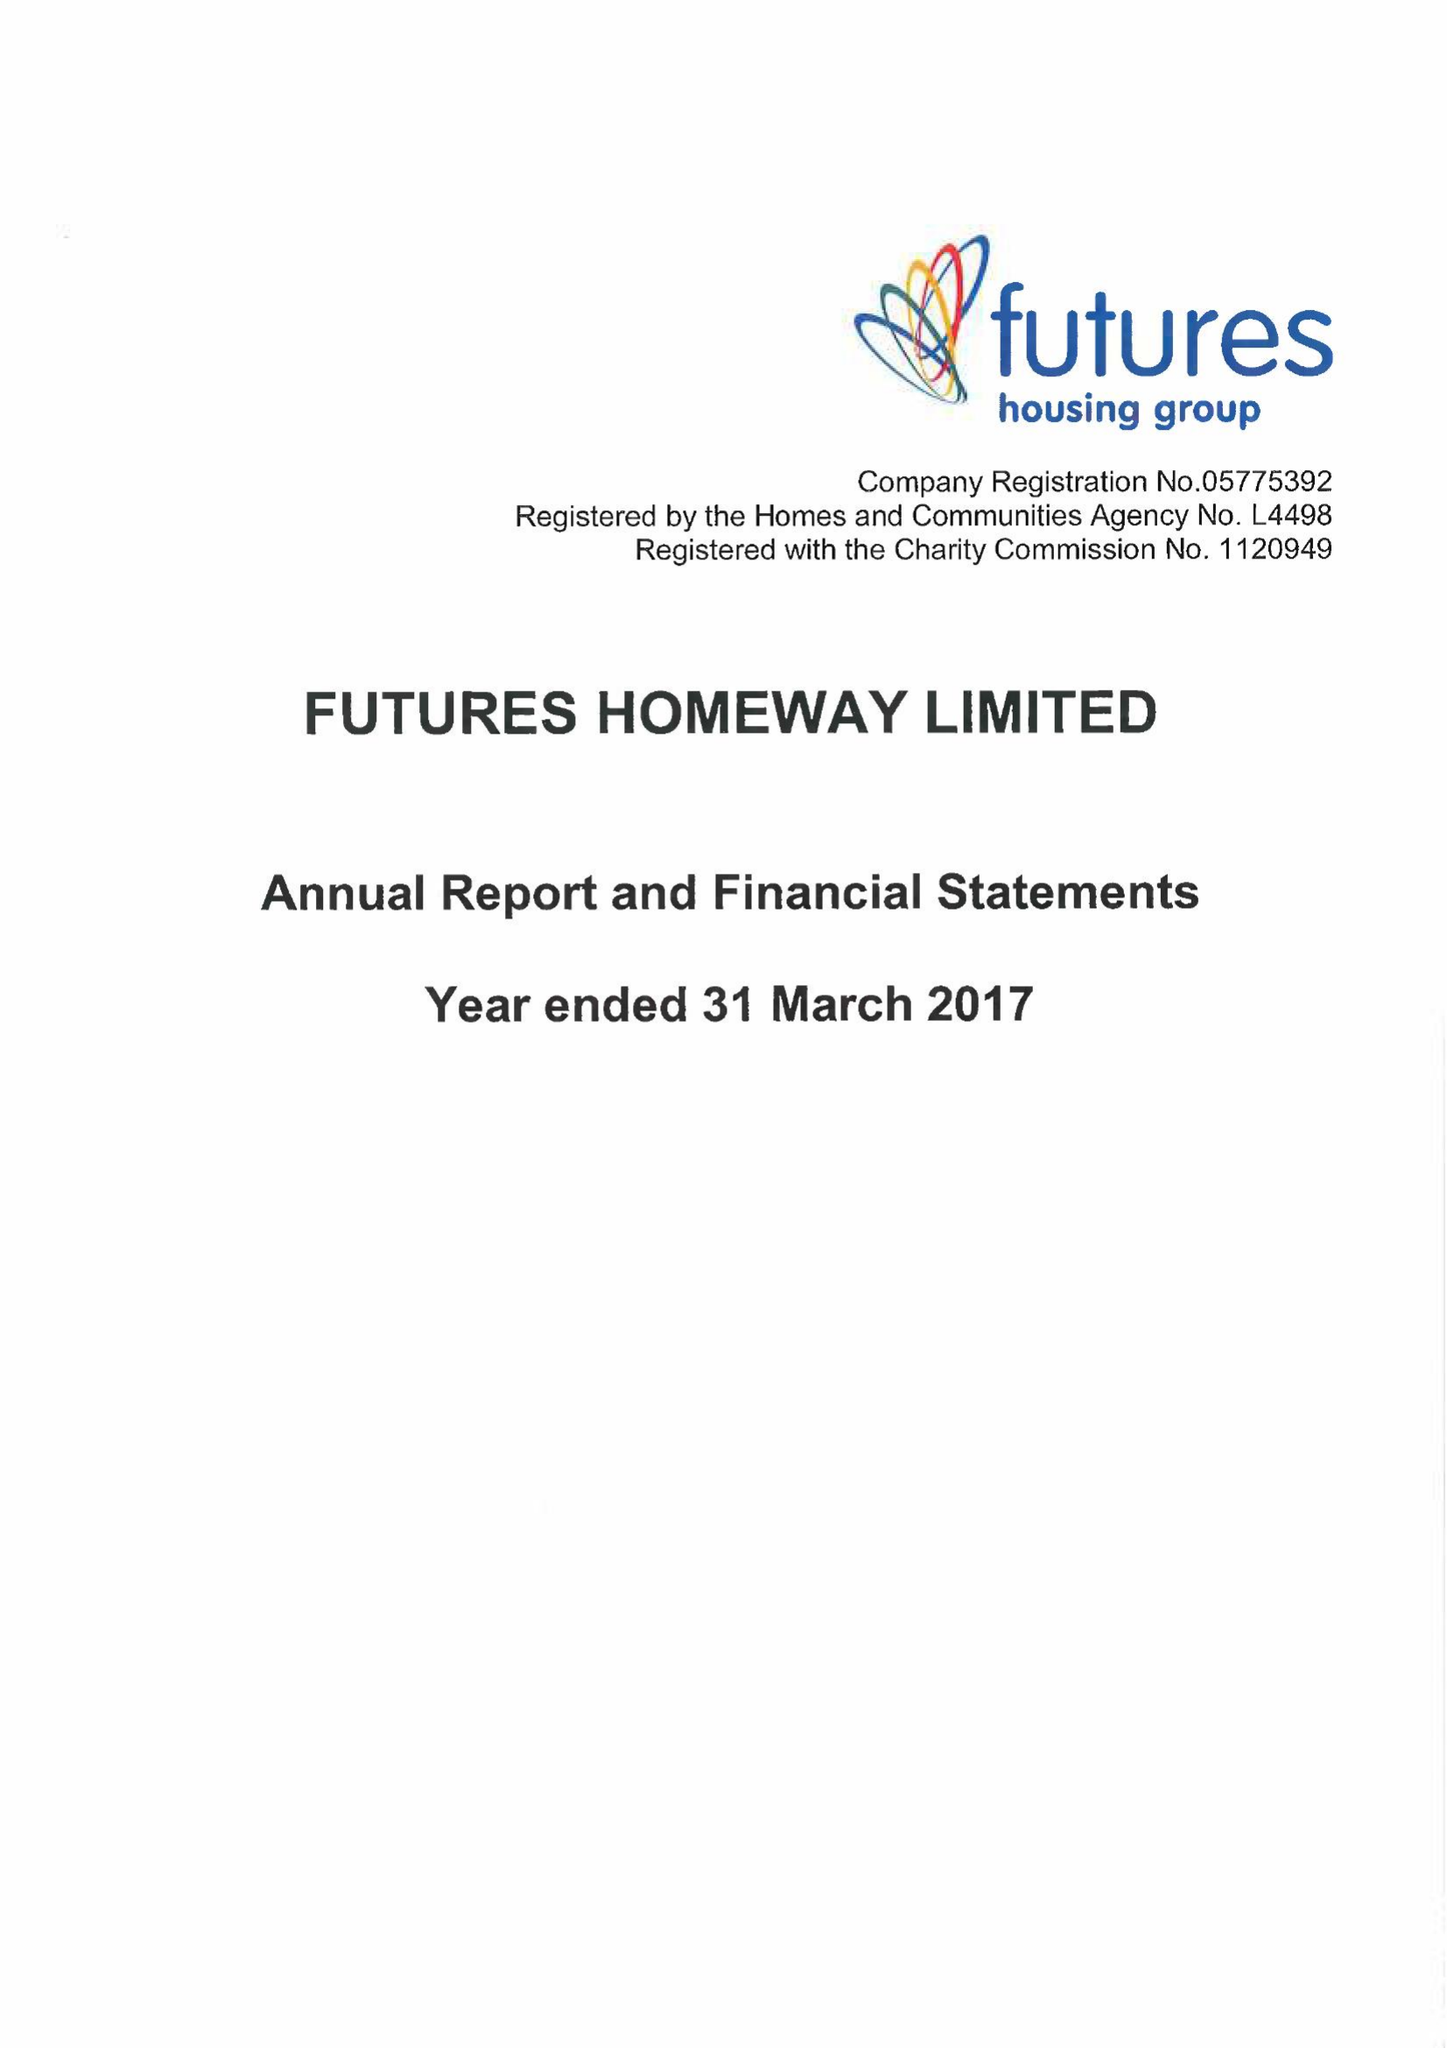What is the value for the charity_number?
Answer the question using a single word or phrase. 1120949 